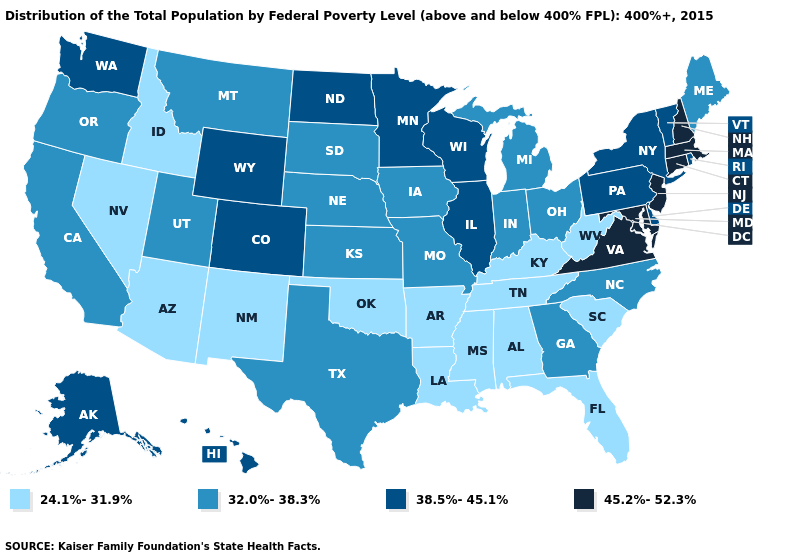Name the states that have a value in the range 45.2%-52.3%?
Be succinct. Connecticut, Maryland, Massachusetts, New Hampshire, New Jersey, Virginia. What is the value of Arizona?
Quick response, please. 24.1%-31.9%. What is the value of North Carolina?
Answer briefly. 32.0%-38.3%. Among the states that border Washington , does Oregon have the lowest value?
Write a very short answer. No. Among the states that border Kentucky , which have the highest value?
Short answer required. Virginia. Does the map have missing data?
Be succinct. No. Does Mississippi have the lowest value in the USA?
Be succinct. Yes. Name the states that have a value in the range 45.2%-52.3%?
Answer briefly. Connecticut, Maryland, Massachusetts, New Hampshire, New Jersey, Virginia. Which states have the lowest value in the USA?
Quick response, please. Alabama, Arizona, Arkansas, Florida, Idaho, Kentucky, Louisiana, Mississippi, Nevada, New Mexico, Oklahoma, South Carolina, Tennessee, West Virginia. Does Oklahoma have the same value as Nebraska?
Write a very short answer. No. Name the states that have a value in the range 38.5%-45.1%?
Be succinct. Alaska, Colorado, Delaware, Hawaii, Illinois, Minnesota, New York, North Dakota, Pennsylvania, Rhode Island, Vermont, Washington, Wisconsin, Wyoming. What is the value of Nevada?
Short answer required. 24.1%-31.9%. Does Georgia have the lowest value in the South?
Quick response, please. No. What is the lowest value in the MidWest?
Concise answer only. 32.0%-38.3%. Name the states that have a value in the range 45.2%-52.3%?
Be succinct. Connecticut, Maryland, Massachusetts, New Hampshire, New Jersey, Virginia. 